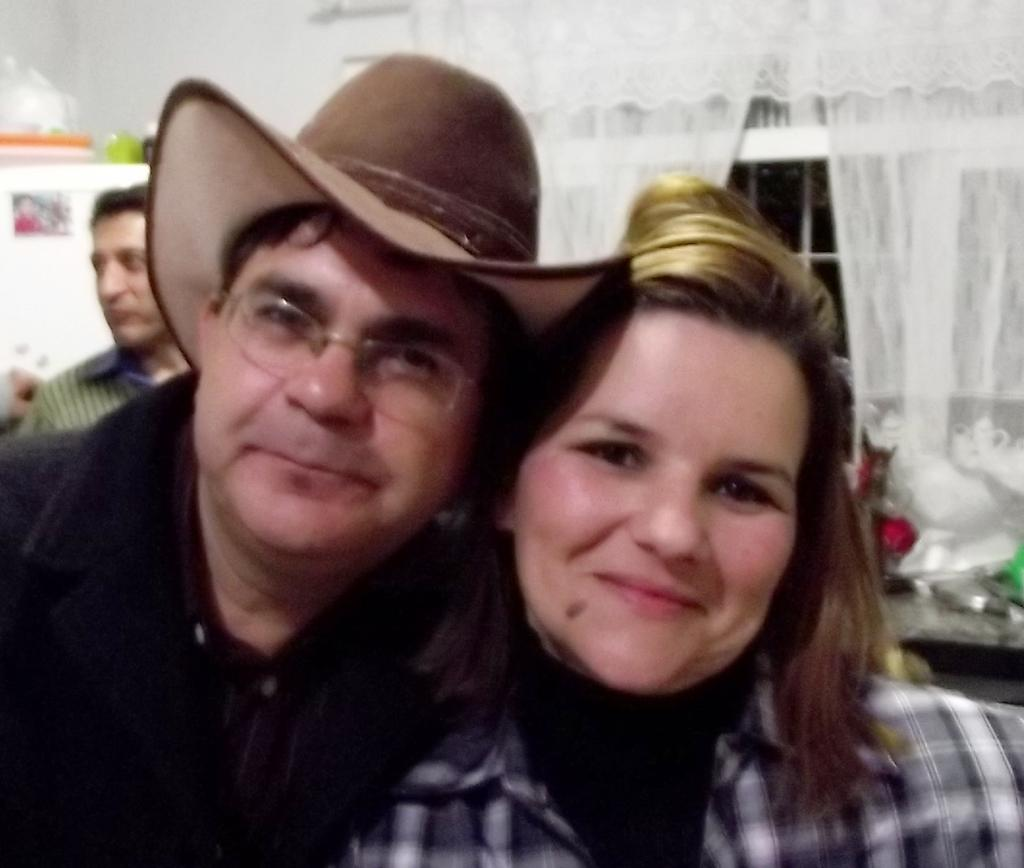How many people are in the image? There are a few persons in the image. What color are the curtains in the image? The curtains in the image are white. Can you describe the window in the image? There is a window in the image. What can be seen on the left side of the image? There are objects on the left side of the image. What type of grain is being harvested by the carpenter in the image? There is no carpenter or grain present in the image. Is the bear visible through the window in the image? There is no bear visible through the window or anywhere else in the image. 